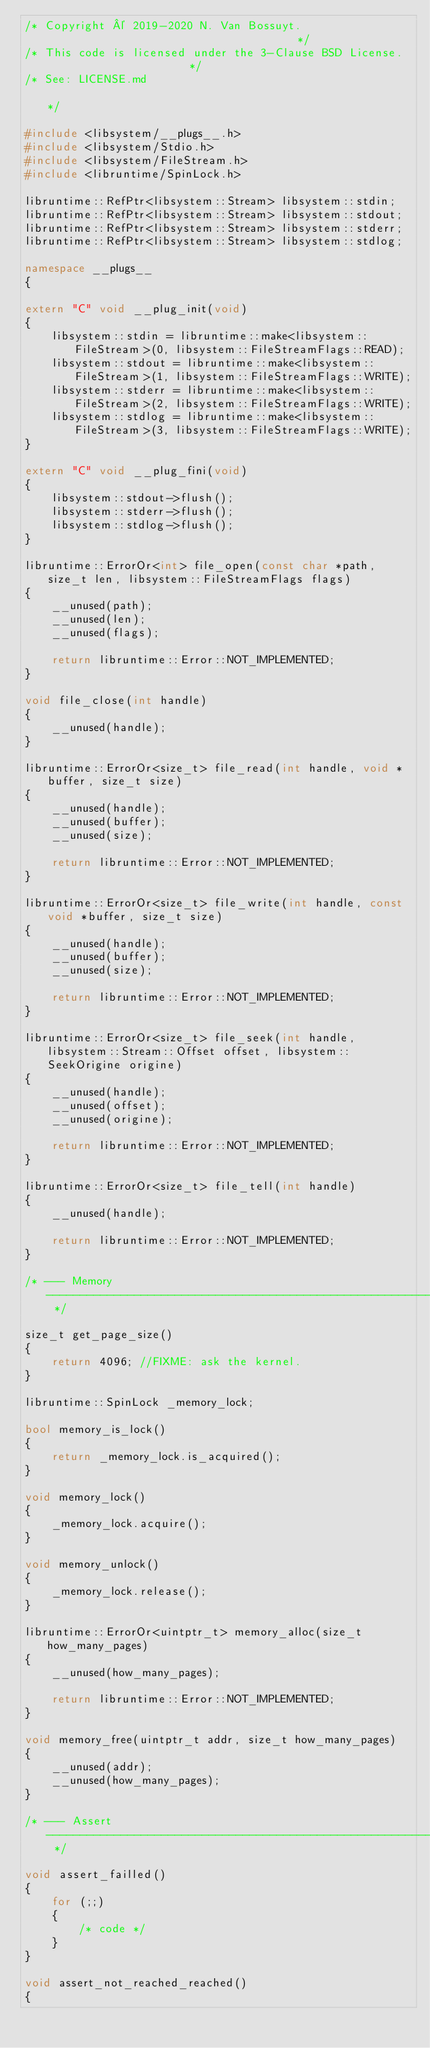Convert code to text. <code><loc_0><loc_0><loc_500><loc_500><_C++_>/* Copyright © 2019-2020 N. Van Bossuyt.                                      */
/* This code is licensed under the 3-Clause BSD License.                      */
/* See: LICENSE.md                                                            */

#include <libsystem/__plugs__.h>
#include <libsystem/Stdio.h>
#include <libsystem/FileStream.h>
#include <libruntime/SpinLock.h>

libruntime::RefPtr<libsystem::Stream> libsystem::stdin;
libruntime::RefPtr<libsystem::Stream> libsystem::stdout;
libruntime::RefPtr<libsystem::Stream> libsystem::stderr;
libruntime::RefPtr<libsystem::Stream> libsystem::stdlog;

namespace __plugs__
{

extern "C" void __plug_init(void)
{
    libsystem::stdin = libruntime::make<libsystem::FileStream>(0, libsystem::FileStreamFlags::READ);
    libsystem::stdout = libruntime::make<libsystem::FileStream>(1, libsystem::FileStreamFlags::WRITE);
    libsystem::stderr = libruntime::make<libsystem::FileStream>(2, libsystem::FileStreamFlags::WRITE);
    libsystem::stdlog = libruntime::make<libsystem::FileStream>(3, libsystem::FileStreamFlags::WRITE);
}

extern "C" void __plug_fini(void)
{
    libsystem::stdout->flush();
    libsystem::stderr->flush();
    libsystem::stdlog->flush();
}

libruntime::ErrorOr<int> file_open(const char *path, size_t len, libsystem::FileStreamFlags flags)
{
    __unused(path);
    __unused(len);
    __unused(flags);

    return libruntime::Error::NOT_IMPLEMENTED;
}

void file_close(int handle)
{
    __unused(handle);
}

libruntime::ErrorOr<size_t> file_read(int handle, void *buffer, size_t size)
{
    __unused(handle);
    __unused(buffer);
    __unused(size);

    return libruntime::Error::NOT_IMPLEMENTED;
}

libruntime::ErrorOr<size_t> file_write(int handle, const void *buffer, size_t size)
{
    __unused(handle);
    __unused(buffer);
    __unused(size);

    return libruntime::Error::NOT_IMPLEMENTED;
}

libruntime::ErrorOr<size_t> file_seek(int handle, libsystem::Stream::Offset offset, libsystem::SeekOrigine origine)
{
    __unused(handle);
    __unused(offset);
    __unused(origine);

    return libruntime::Error::NOT_IMPLEMENTED;
}

libruntime::ErrorOr<size_t> file_tell(int handle)
{
    __unused(handle);

    return libruntime::Error::NOT_IMPLEMENTED;
}

/* --- Memory --------------------------------------------------------------- */

size_t get_page_size()
{
    return 4096; //FIXME: ask the kernel.
}

libruntime::SpinLock _memory_lock;

bool memory_is_lock()
{
    return _memory_lock.is_acquired();
}

void memory_lock()
{
    _memory_lock.acquire();
}

void memory_unlock()
{
    _memory_lock.release();
}

libruntime::ErrorOr<uintptr_t> memory_alloc(size_t how_many_pages)
{
    __unused(how_many_pages);

    return libruntime::Error::NOT_IMPLEMENTED;
}

void memory_free(uintptr_t addr, size_t how_many_pages)
{
    __unused(addr);
    __unused(how_many_pages);
}

/* --- Assert --------------------------------------------------------------- */

void assert_failled()
{
    for (;;)
    {
        /* code */
    }
}

void assert_not_reached_reached()
{</code> 